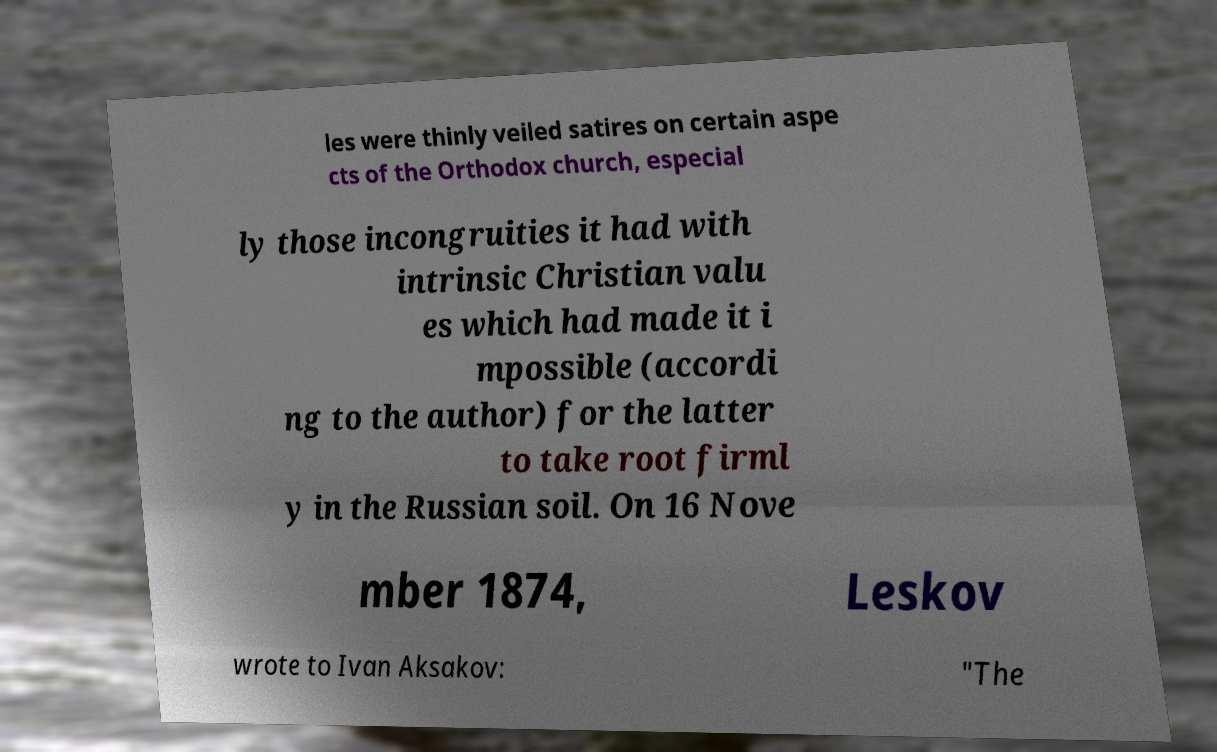What messages or text are displayed in this image? I need them in a readable, typed format. les were thinly veiled satires on certain aspe cts of the Orthodox church, especial ly those incongruities it had with intrinsic Christian valu es which had made it i mpossible (accordi ng to the author) for the latter to take root firml y in the Russian soil. On 16 Nove mber 1874, Leskov wrote to Ivan Aksakov: "The 